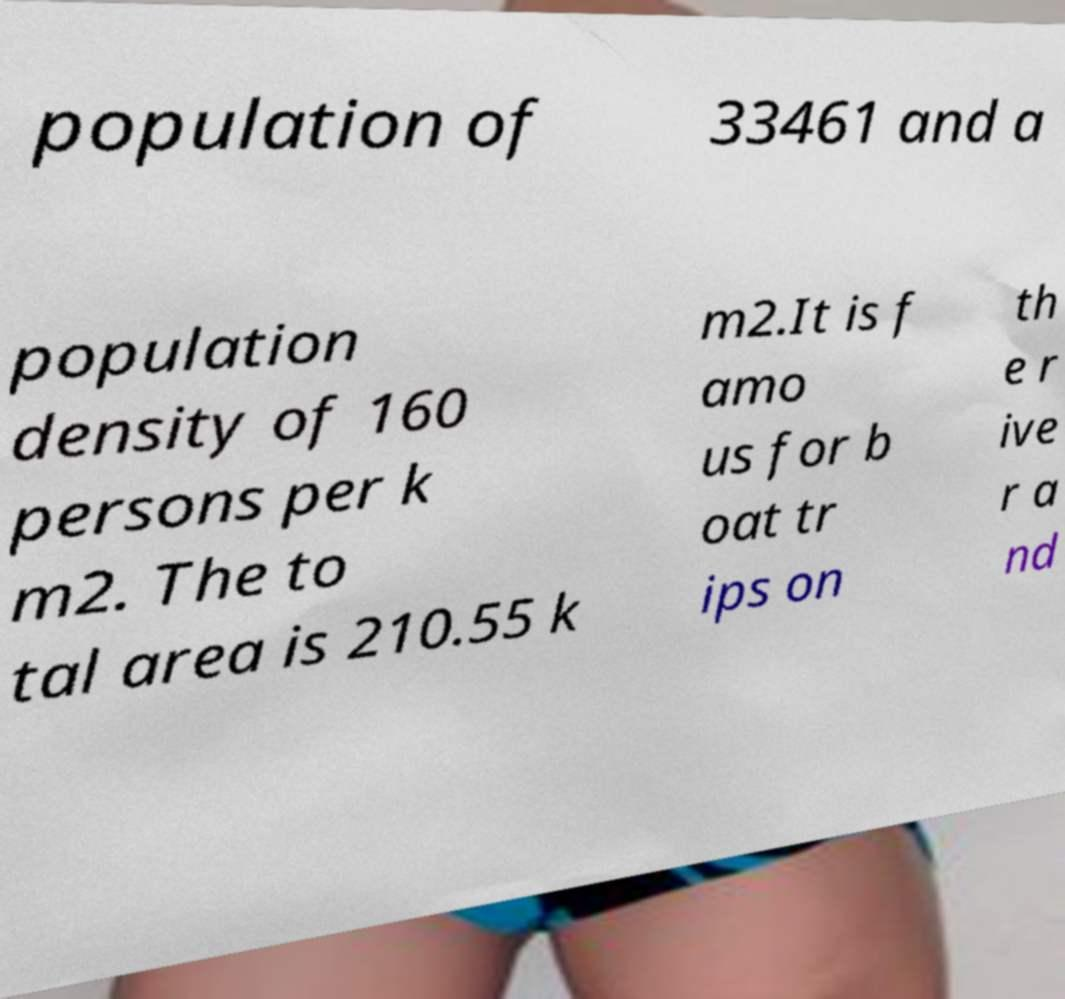What messages or text are displayed in this image? I need them in a readable, typed format. population of 33461 and a population density of 160 persons per k m2. The to tal area is 210.55 k m2.It is f amo us for b oat tr ips on th e r ive r a nd 